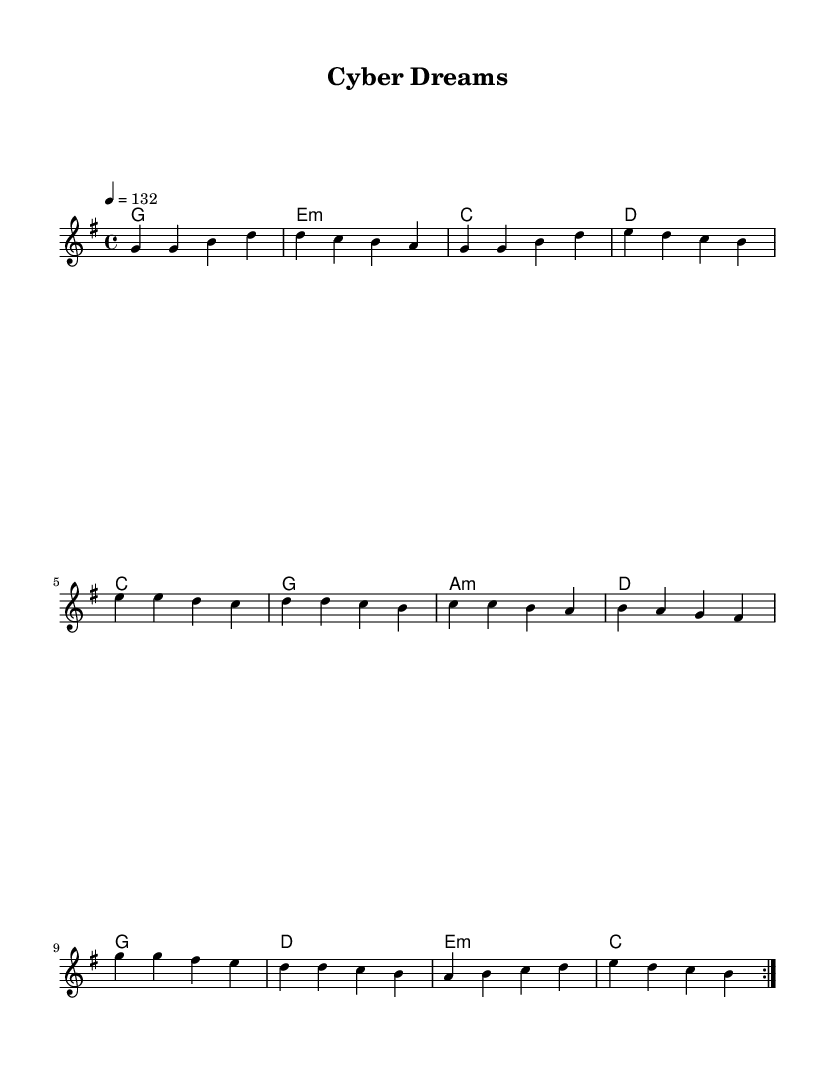What is the key signature of this music? The key signature is G major, which has one sharp (F#).
Answer: G major What is the time signature of this piece? The time signature is 4/4, meaning there are four beats per measure.
Answer: 4/4 What is the tempo marking indicated in the music? The tempo is marked at a quarter note equals 132 beats per minute.
Answer: 132 How many times is the melody repeated? The melody is repeated two times as indicated by "volta 2."
Answer: 2 What is the first chord used in the piece? The first chord in the harmony section is G major, as evident from the chord mode.
Answer: G What musical elements demonstrate K-Pop's upbeat style in this piece? The piece features an energetic tempo and repetitive melodic structure, common in K-Pop music.
Answer: Energetic tempo and repetition How does the harmony contribute to the uplifting theme of overcoming challenges? The use of major chords, particularly G major and E minor, creates a bright and positive sound that aligns with the theme of overcoming obstacles.
Answer: Major chords 